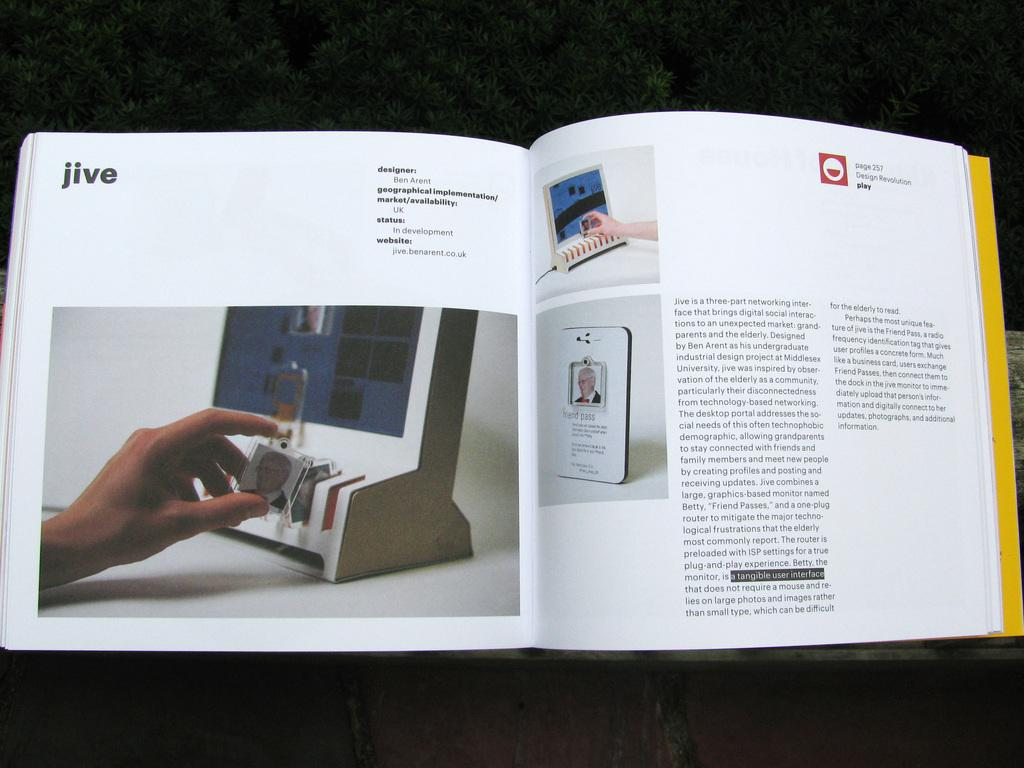<image>
Provide a brief description of the given image. A book is open to a page about jive. 